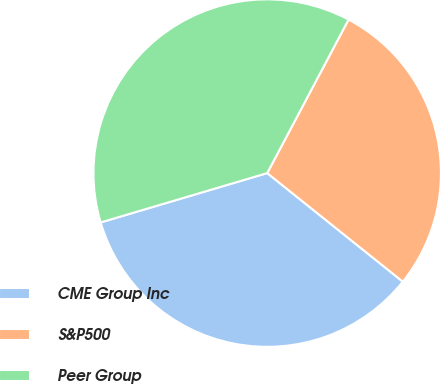Convert chart to OTSL. <chart><loc_0><loc_0><loc_500><loc_500><pie_chart><fcel>CME Group Inc<fcel>S&P500<fcel>Peer Group<nl><fcel>34.67%<fcel>27.99%<fcel>37.34%<nl></chart> 